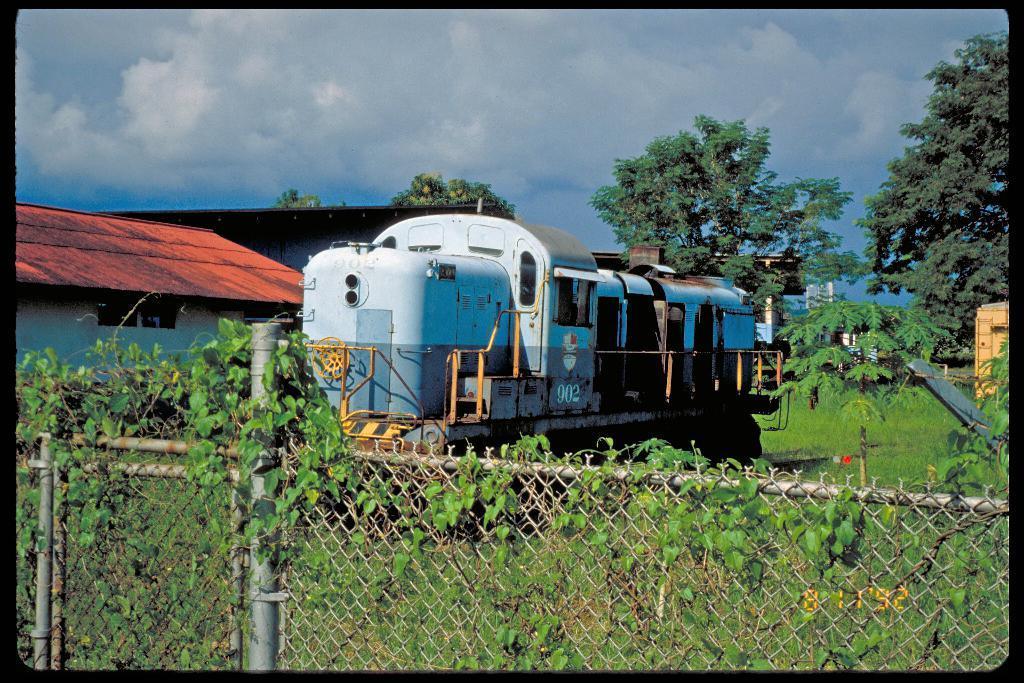Describe this image in one or two sentences. In the center of the we can see railway engine on the track. On the left side of the image we can see houses. In the background we can see trees, sky and clouds. In the foreground we can see fencing and creepers. 